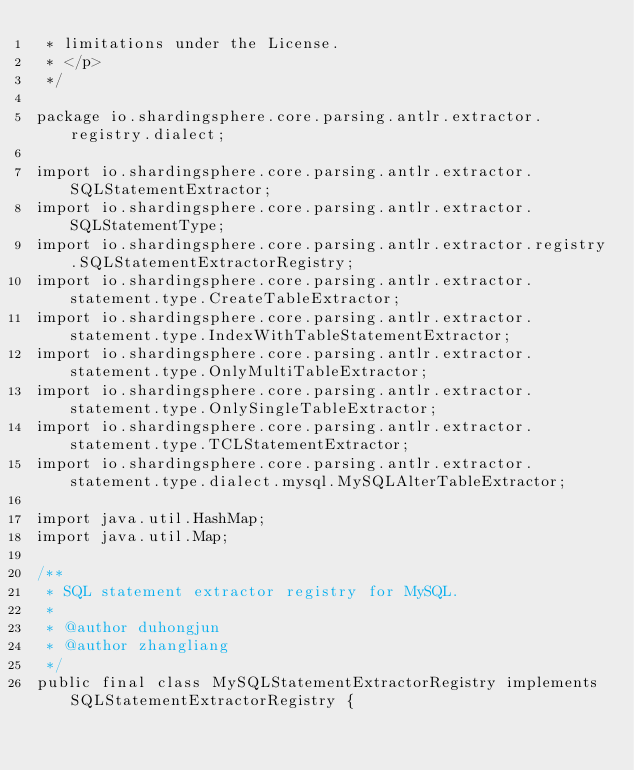Convert code to text. <code><loc_0><loc_0><loc_500><loc_500><_Java_> * limitations under the License.
 * </p>
 */

package io.shardingsphere.core.parsing.antlr.extractor.registry.dialect;

import io.shardingsphere.core.parsing.antlr.extractor.SQLStatementExtractor;
import io.shardingsphere.core.parsing.antlr.extractor.SQLStatementType;
import io.shardingsphere.core.parsing.antlr.extractor.registry.SQLStatementExtractorRegistry;
import io.shardingsphere.core.parsing.antlr.extractor.statement.type.CreateTableExtractor;
import io.shardingsphere.core.parsing.antlr.extractor.statement.type.IndexWithTableStatementExtractor;
import io.shardingsphere.core.parsing.antlr.extractor.statement.type.OnlyMultiTableExtractor;
import io.shardingsphere.core.parsing.antlr.extractor.statement.type.OnlySingleTableExtractor;
import io.shardingsphere.core.parsing.antlr.extractor.statement.type.TCLStatementExtractor;
import io.shardingsphere.core.parsing.antlr.extractor.statement.type.dialect.mysql.MySQLAlterTableExtractor;

import java.util.HashMap;
import java.util.Map;

/**
 * SQL statement extractor registry for MySQL.
 * 
 * @author duhongjun
 * @author zhangliang
 */
public final class MySQLStatementExtractorRegistry implements SQLStatementExtractorRegistry {
    </code> 